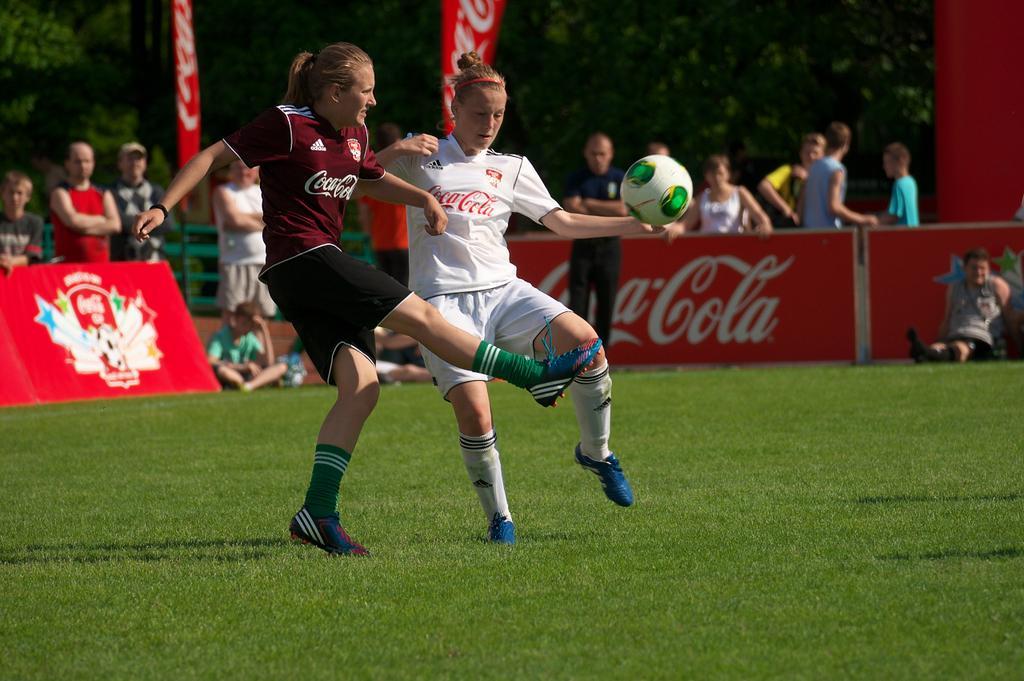Please provide a concise description of this image. In this image we can see two people standing on the ground. We can also see a ball and some grass. On the backside we can see a group of people standing beside a fence, some people sitting on the ground. We can also see the flags and some trees. 